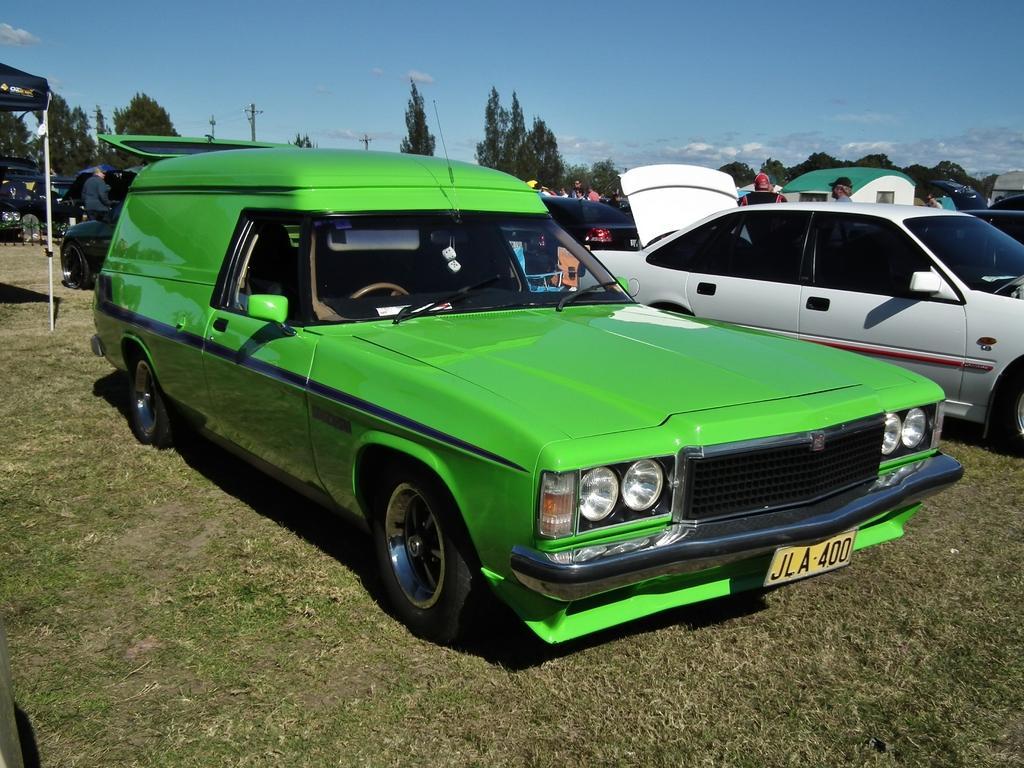Please provide a concise description of this image. In this image there is a grassy land in the bottom of this image, and there are some cars in the middle of this image. There are some trees in the background. There is a sky on the top of this image. 